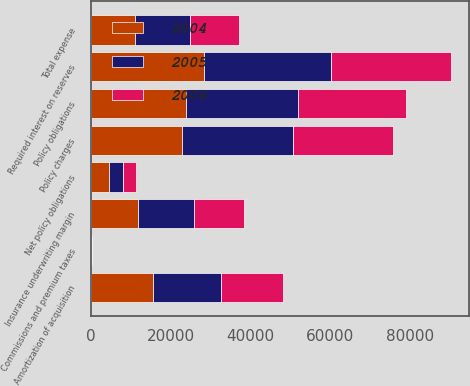<chart> <loc_0><loc_0><loc_500><loc_500><stacked_bar_chart><ecel><fcel>Policy charges<fcel>Policy obligations<fcel>Required interest on reserves<fcel>Net policy obligations<fcel>Commissions and premium taxes<fcel>Amortization of acquisition<fcel>Total expense<fcel>Insurance underwriting margin<nl><fcel>2004<fcel>22914<fcel>23743<fcel>28318<fcel>4575<fcel>88<fcel>15486<fcel>10999<fcel>11915<nl><fcel>2006<fcel>24929<fcel>26888<fcel>30092<fcel>3204<fcel>49<fcel>15504<fcel>12349<fcel>12580<nl><fcel>2005<fcel>27744<fcel>28248<fcel>31740<fcel>3492<fcel>61<fcel>17211<fcel>13780<fcel>13964<nl></chart> 